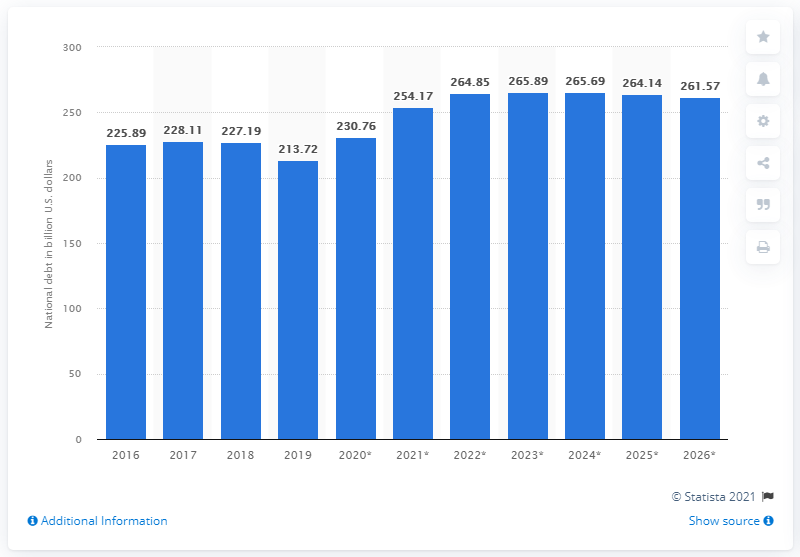Draw attention to some important aspects in this diagram. In 2019, Sweden's national debt was 213.72 dollars. 